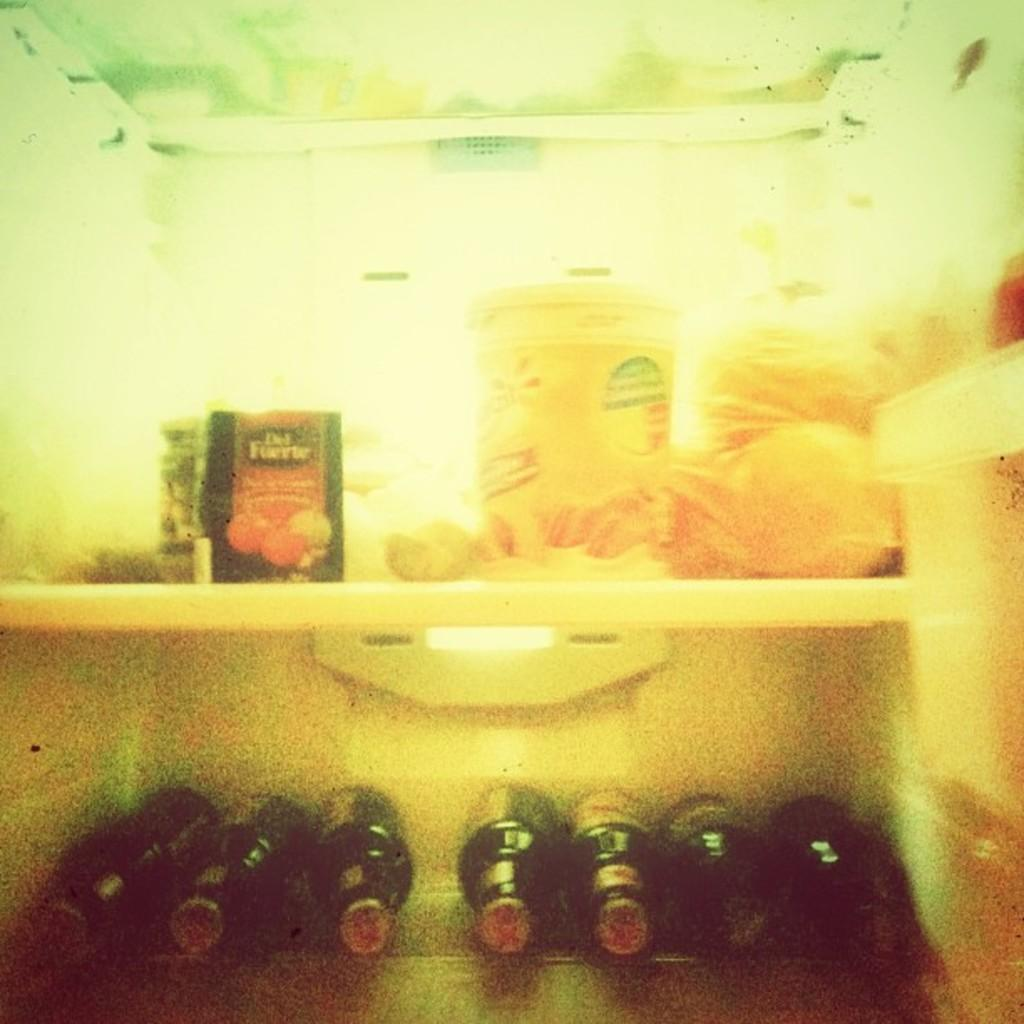What type of appliance is in the center of the image? There is a refrigerator in the center of the image. What is inside the refrigerator? There are bottles and other stock inside the refrigerator. What type of bait is being used to attract attention to the rail in the image? There is no bait, attention, or rail present in the image. 